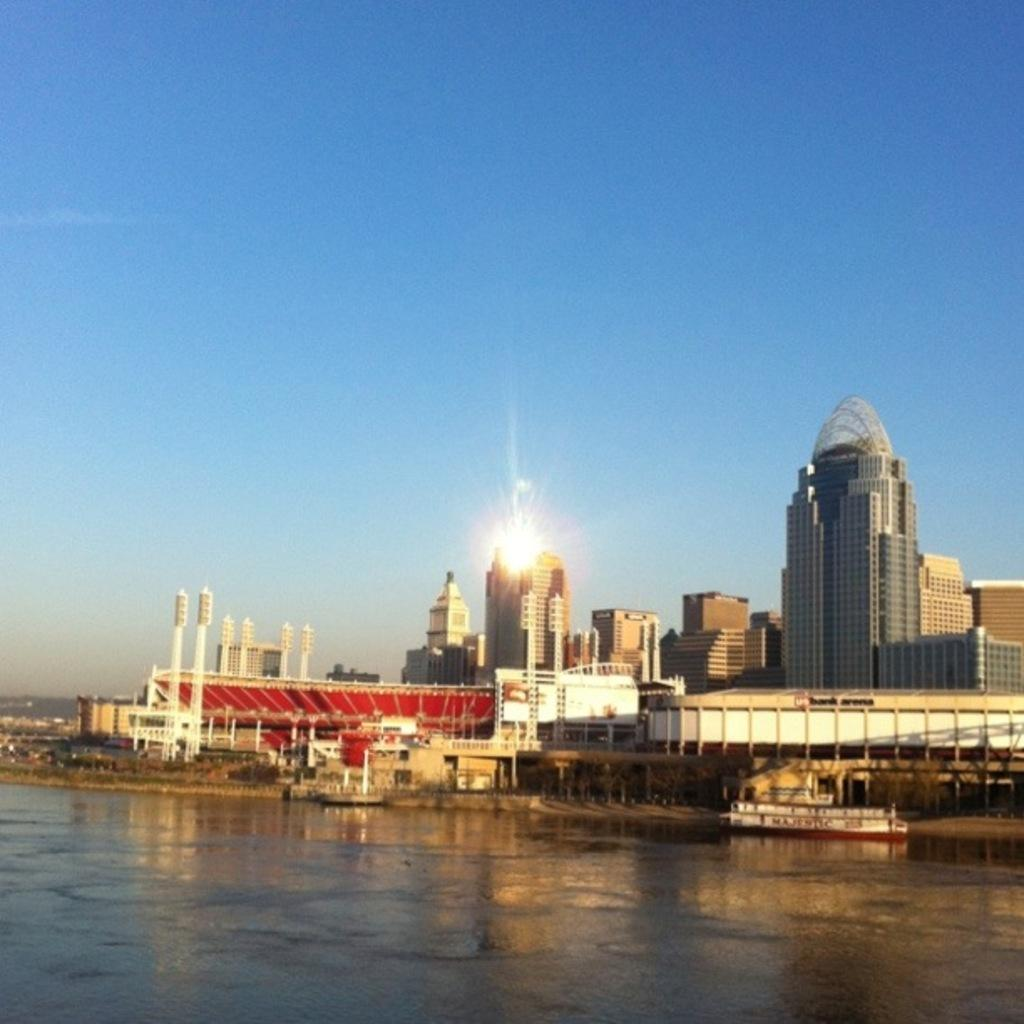What is the location of the image? The image is taken near the ocean. What can be seen in the foreground of the image? There are boats in the front of the image. What type of structures are visible in the image? There are buildings and skyscrapers in the image. What is the condition of the sky in the image? The sun is visible in the sky at the top of the image. How many cameras are being used to take the picture in the image? There is no camera visible in the image, as the image itself is being observed. What type of trip is being taken by the people in the image? There is no indication of a trip in the image; it simply shows boats, buildings, and the sky. 